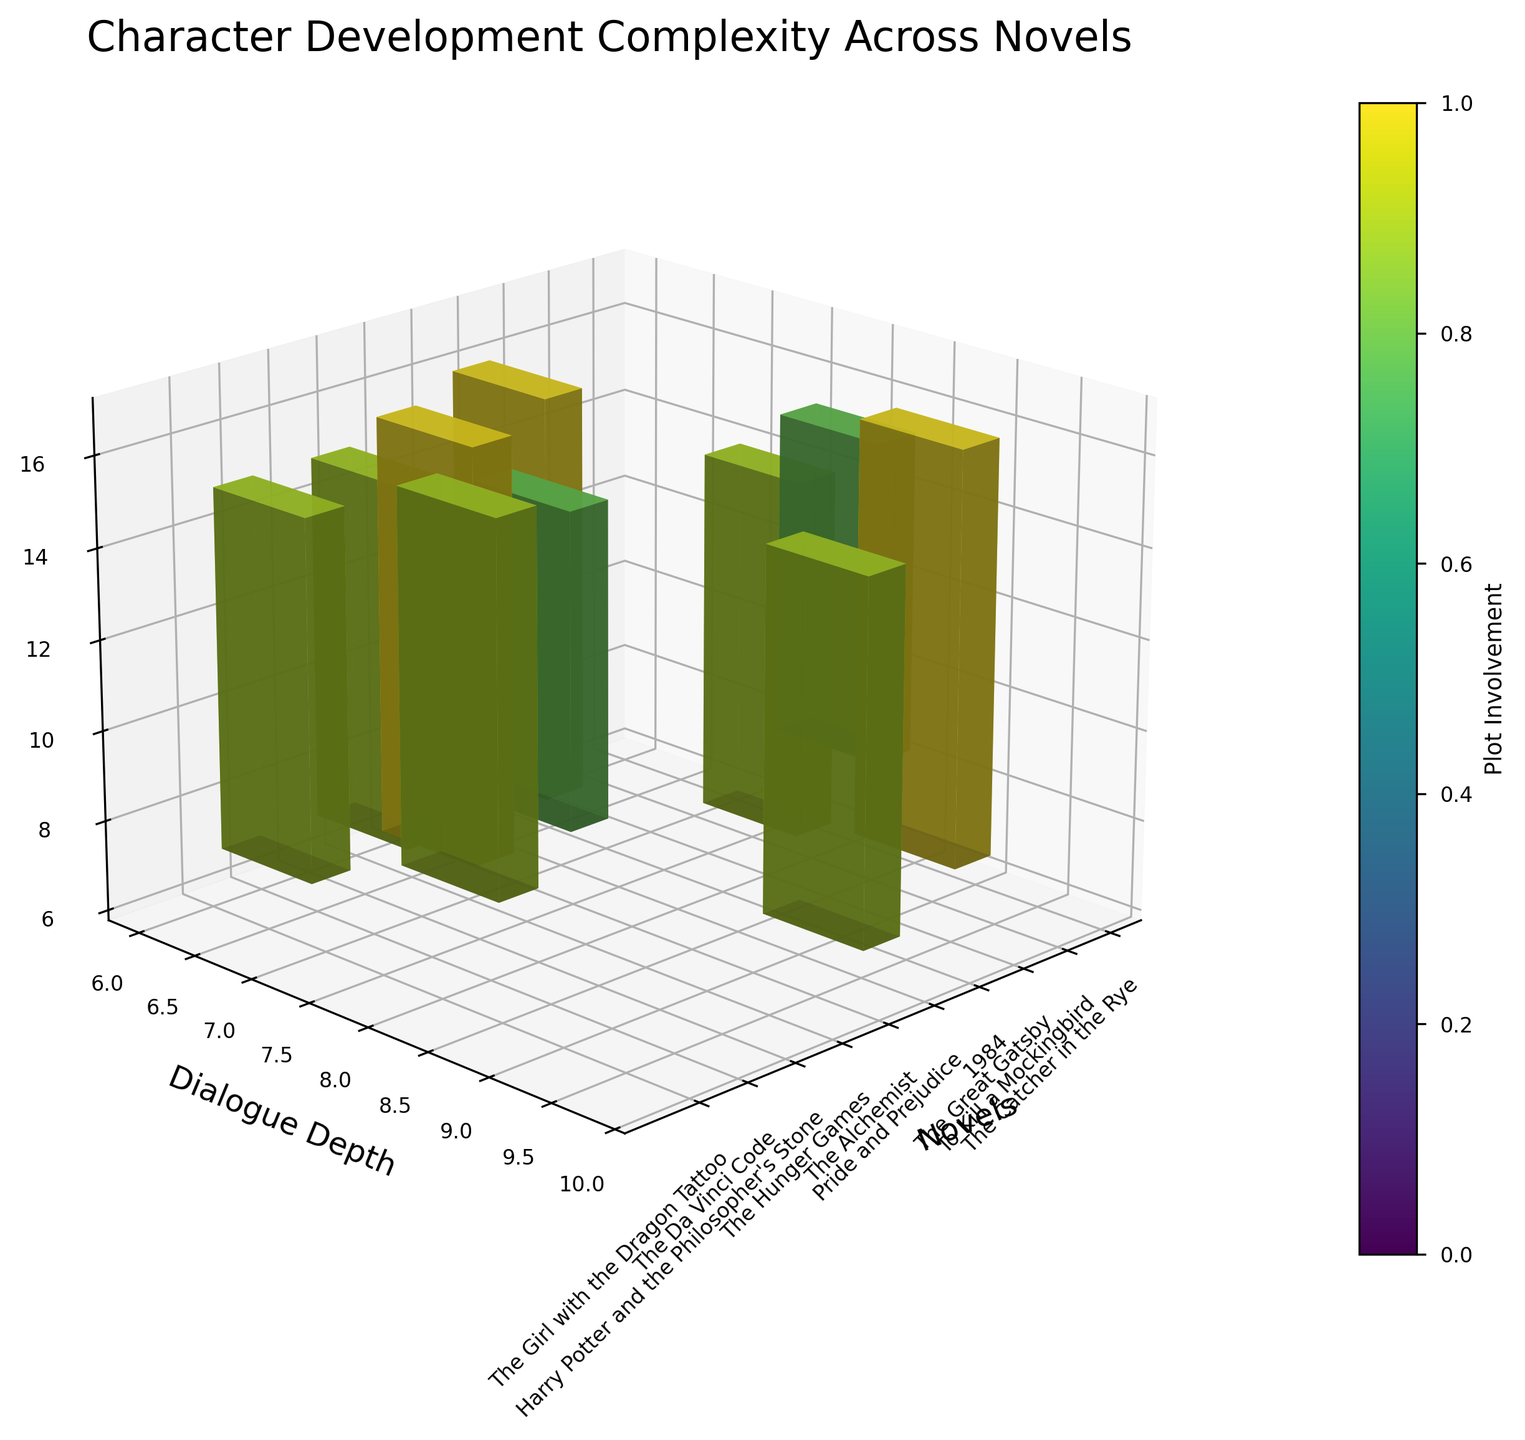what is the title of the plot? The title is always located at the top of the plot. By looking at the top of the plot, you can see the displayed title text.
Answer: Character Development Complexity Across Novels What novel has the highest Dialogue Depth? Locate the 'Dialogue Depth' axis and find the bar that reaches the highest value along this axis. The corresponding novel can be identified from the labels on the 'Novels' axis.
Answer: Pride and Prejudice, The Great Gatsby Which novels have equal Dialogue Depth but different Plot Involvement? Compare the height of bars for Dialogue Depth that match in height but check along the 'Plot Involvement' axis to see differences.
Answer: The Catcher in the Rye and The Alchemist How many novels have a Backstory Richness of 8? Look at the 'Backstory Richness' axis and count the number of bars reaching the value 8 on this axis.
Answer: 3 What is the average Dialogue Depth among all the novels? Look up all the Dialogue Depth values along the respective axis, sum them up, and then divide by the number of novels (10). Compute (7+8+9+6+9+7+6+7+6+8)/10 = 73/10.
Answer: 7.3 Which novel features the highest Plot Involvement? Search for the maximum bar extension along the 'Plot Involvement' color scale or the value provided in the color bar legend.
Answer: The Great Gatsby, 1984, and Harry Potter and the Philosopher's Stone Compare the Dialogue Depth and Backstory Richness values for "To Kill a Mockingbird." Are they higher than "The Da Vinci Code"? Check the 'Dialogue Depth' and 'Backstory Richness' values for both novels from the respective axis and compare these values.
Answer: Yes, both values are higher for "To Kill a Mockingbird" Which novels have both Dialogue Depth and Backstory Richness greater than 7? Identify bars reaching beyond the values 7 along both 'Dialogue Depth' and 'Backstory Richness' axes and find their corresponding novel names.
Answer: The Great Gatsby, The Alchemist, The Girl with the Dragon Tattoo Determine the average Backstory Richness for novels with a Dialogue Depth of 7. Identify novels with a Dialogue Depth of 7, note their Backstory Richness values, sum these values, and divide by the number of such novels (4). Compute (6+8+8+8)/4 = 30/4.
Answer: 7.5 Which novel has the highest value for all three measures (Dialogue Depth, Backstory Richness, Plot Involvement)? Search for the highest values across all three axes simultaneously and identify the novel corresponding to that bar.
Answer: The Great Gatsby 